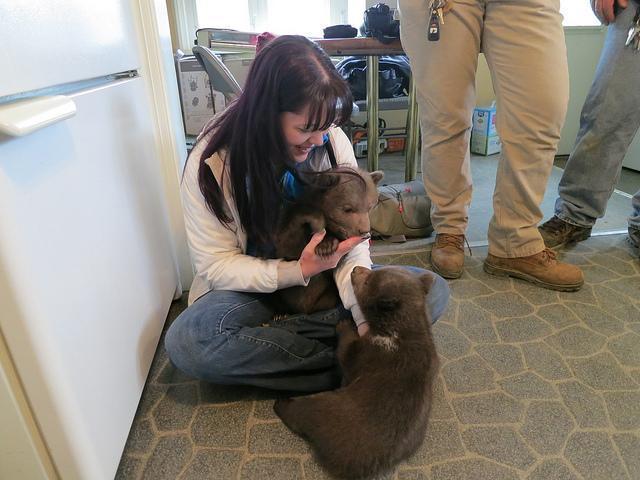How many people can you see?
Give a very brief answer. 3. How many bears can be seen?
Give a very brief answer. 2. 